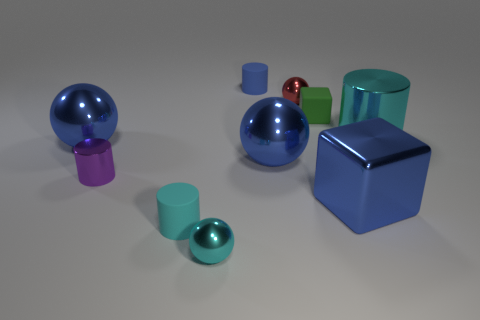Subtract all yellow cylinders. How many blue balls are left? 2 Subtract all blue rubber cylinders. How many cylinders are left? 3 Subtract all cyan spheres. How many spheres are left? 3 Subtract all blue cylinders. Subtract all red spheres. How many cylinders are left? 3 Subtract all blocks. How many objects are left? 8 Add 2 small cyan objects. How many small cyan objects exist? 4 Subtract 0 gray cylinders. How many objects are left? 10 Subtract all red metal things. Subtract all large balls. How many objects are left? 7 Add 4 large blue metal blocks. How many large blue metal blocks are left? 5 